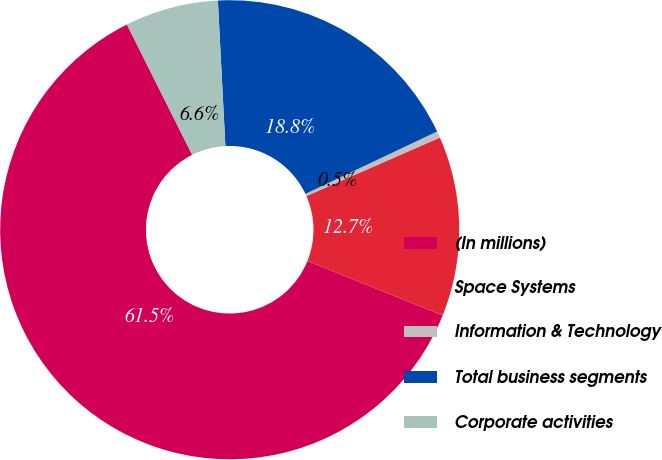Convert chart. <chart><loc_0><loc_0><loc_500><loc_500><pie_chart><fcel>(In millions)<fcel>Space Systems<fcel>Information & Technology<fcel>Total business segments<fcel>Corporate activities<nl><fcel>61.52%<fcel>12.67%<fcel>0.46%<fcel>18.78%<fcel>6.57%<nl></chart> 